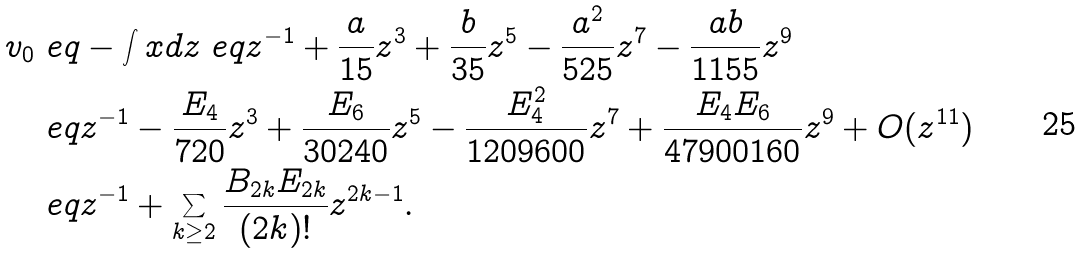Convert formula to latex. <formula><loc_0><loc_0><loc_500><loc_500>v _ { 0 } & \ e q - \int x d z \ e q z ^ { - 1 } + \frac { a } { 1 5 } z ^ { 3 } + \frac { b } { 3 5 } z ^ { 5 } - \frac { a ^ { 2 } } { 5 2 5 } z ^ { 7 } - \frac { a b } { 1 1 5 5 } z ^ { 9 } \\ & \ e q z ^ { - 1 } - \frac { E _ { 4 } } { 7 2 0 } z ^ { 3 } + \frac { E _ { 6 } } { 3 0 2 4 0 } z ^ { 5 } - \frac { E _ { 4 } ^ { 2 } } { 1 2 0 9 6 0 0 } z ^ { 7 } + \frac { E _ { 4 } E _ { 6 } } { 4 7 9 0 0 1 6 0 } z ^ { 9 } + O ( z ^ { 1 1 } ) \\ & \ e q z ^ { - 1 } + \sum _ { k \geq 2 } \frac { B _ { 2 k } E _ { 2 k } } { ( 2 k ) ! } z ^ { 2 k - 1 } .</formula> 